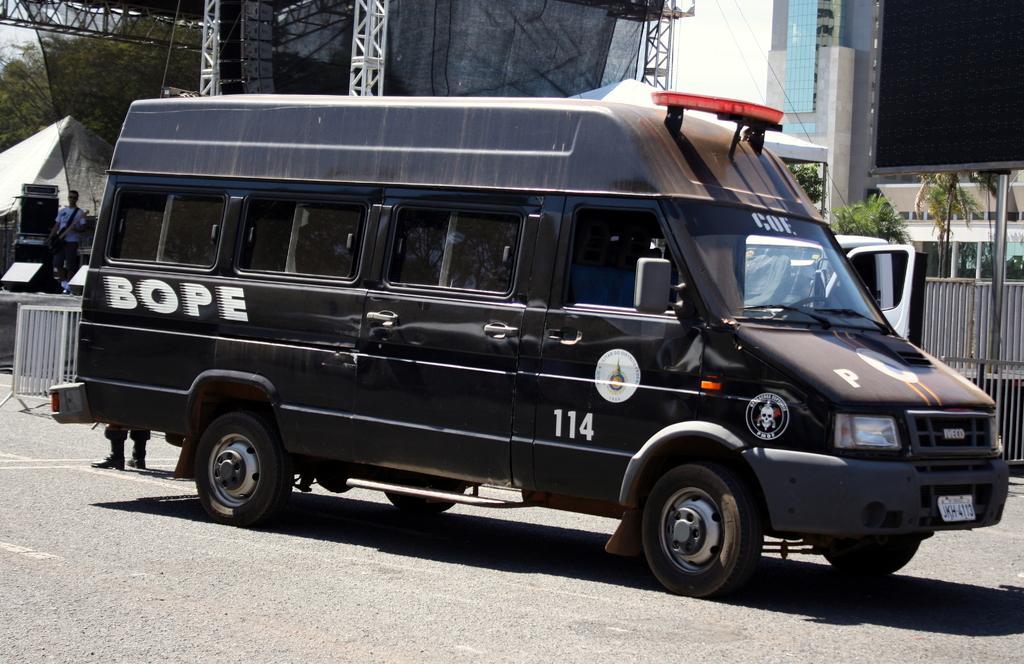Could you give a brief overview of what you see in this image? In this image we can see a black color van on the road. Behind building, pole, board and trees are there. Left side of the image one fencing and man is standing. 